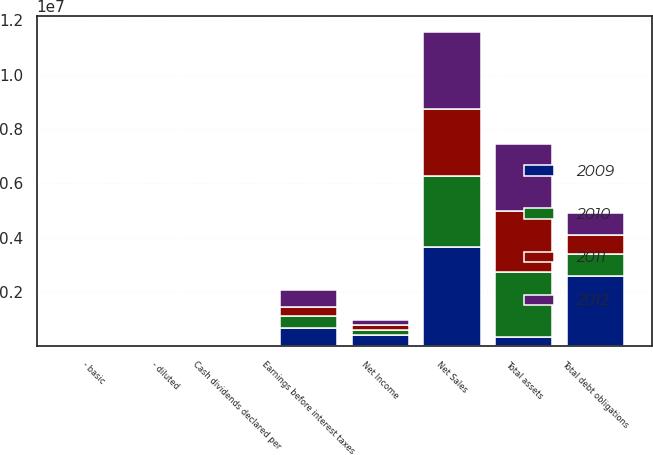Convert chart. <chart><loc_0><loc_0><loc_500><loc_500><stacked_bar_chart><ecel><fcel>Net Sales<fcel>Net Income<fcel>- basic<fcel>- diluted<fcel>Earnings before interest taxes<fcel>Cash dividends declared per<fcel>Total assets<fcel>Total debt obligations<nl><fcel>2009<fcel>3.66531e+06<fcel>436283<fcel>4.52<fcel>4.47<fcel>675400<fcel>1.51<fcel>341680<fcel>2.57275e+06<nl><fcel>2012<fcel>2.84388e+06<fcel>163820<fcel>1.7<fcel>1.68<fcel>614201<fcel>1<fcel>2.45377e+06<fcel>819498<nl><fcel>2010<fcel>2.62011e+06<fcel>158027<fcel>1.59<fcel>1.57<fcel>436383<fcel>0.8<fcel>2.4125e+06<fcel>830280<nl><fcel>2011<fcel>2.43561e+06<fcel>205435<fcel>2.02<fcel>2<fcel>341680<fcel>0.6<fcel>2.22591e+06<fcel>680601<nl></chart> 